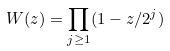<formula> <loc_0><loc_0><loc_500><loc_500>W ( z ) = \prod _ { j \geq 1 } ( 1 - z / 2 ^ { j } )</formula> 